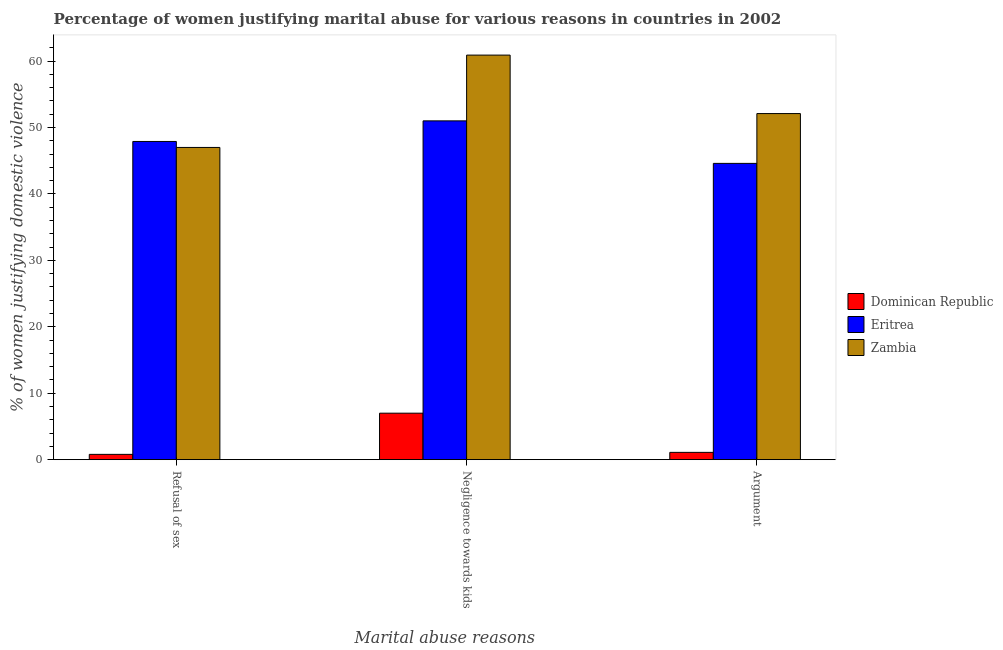How many groups of bars are there?
Keep it short and to the point. 3. Are the number of bars on each tick of the X-axis equal?
Give a very brief answer. Yes. What is the label of the 3rd group of bars from the left?
Your answer should be compact. Argument. What is the percentage of women justifying domestic violence due to arguments in Zambia?
Make the answer very short. 52.1. Across all countries, what is the maximum percentage of women justifying domestic violence due to refusal of sex?
Offer a very short reply. 47.9. Across all countries, what is the minimum percentage of women justifying domestic violence due to refusal of sex?
Provide a short and direct response. 0.8. In which country was the percentage of women justifying domestic violence due to arguments maximum?
Your answer should be very brief. Zambia. In which country was the percentage of women justifying domestic violence due to refusal of sex minimum?
Your response must be concise. Dominican Republic. What is the total percentage of women justifying domestic violence due to negligence towards kids in the graph?
Keep it short and to the point. 118.9. What is the difference between the percentage of women justifying domestic violence due to arguments in Dominican Republic and that in Eritrea?
Provide a short and direct response. -43.5. What is the difference between the percentage of women justifying domestic violence due to negligence towards kids in Dominican Republic and the percentage of women justifying domestic violence due to refusal of sex in Eritrea?
Offer a terse response. -40.9. What is the average percentage of women justifying domestic violence due to refusal of sex per country?
Provide a short and direct response. 31.9. What is the difference between the percentage of women justifying domestic violence due to negligence towards kids and percentage of women justifying domestic violence due to refusal of sex in Dominican Republic?
Offer a very short reply. 6.2. In how many countries, is the percentage of women justifying domestic violence due to arguments greater than 52 %?
Your answer should be compact. 1. What is the ratio of the percentage of women justifying domestic violence due to refusal of sex in Dominican Republic to that in Zambia?
Give a very brief answer. 0.02. Is the percentage of women justifying domestic violence due to negligence towards kids in Eritrea less than that in Dominican Republic?
Offer a terse response. No. What is the difference between the highest and the second highest percentage of women justifying domestic violence due to refusal of sex?
Provide a short and direct response. 0.9. What is the difference between the highest and the lowest percentage of women justifying domestic violence due to arguments?
Give a very brief answer. 51. In how many countries, is the percentage of women justifying domestic violence due to arguments greater than the average percentage of women justifying domestic violence due to arguments taken over all countries?
Offer a terse response. 2. Is the sum of the percentage of women justifying domestic violence due to arguments in Eritrea and Zambia greater than the maximum percentage of women justifying domestic violence due to refusal of sex across all countries?
Offer a very short reply. Yes. What does the 1st bar from the left in Refusal of sex represents?
Give a very brief answer. Dominican Republic. What does the 1st bar from the right in Refusal of sex represents?
Your response must be concise. Zambia. Are all the bars in the graph horizontal?
Ensure brevity in your answer.  No. Does the graph contain any zero values?
Make the answer very short. No. Does the graph contain grids?
Your answer should be very brief. No. What is the title of the graph?
Provide a succinct answer. Percentage of women justifying marital abuse for various reasons in countries in 2002. Does "Barbados" appear as one of the legend labels in the graph?
Offer a terse response. No. What is the label or title of the X-axis?
Provide a succinct answer. Marital abuse reasons. What is the label or title of the Y-axis?
Ensure brevity in your answer.  % of women justifying domestic violence. What is the % of women justifying domestic violence of Eritrea in Refusal of sex?
Provide a succinct answer. 47.9. What is the % of women justifying domestic violence of Zambia in Refusal of sex?
Provide a short and direct response. 47. What is the % of women justifying domestic violence in Zambia in Negligence towards kids?
Give a very brief answer. 60.9. What is the % of women justifying domestic violence of Eritrea in Argument?
Your answer should be very brief. 44.6. What is the % of women justifying domestic violence in Zambia in Argument?
Your response must be concise. 52.1. Across all Marital abuse reasons, what is the maximum % of women justifying domestic violence in Eritrea?
Provide a succinct answer. 51. Across all Marital abuse reasons, what is the maximum % of women justifying domestic violence in Zambia?
Make the answer very short. 60.9. Across all Marital abuse reasons, what is the minimum % of women justifying domestic violence of Dominican Republic?
Offer a very short reply. 0.8. Across all Marital abuse reasons, what is the minimum % of women justifying domestic violence of Eritrea?
Your answer should be very brief. 44.6. Across all Marital abuse reasons, what is the minimum % of women justifying domestic violence in Zambia?
Make the answer very short. 47. What is the total % of women justifying domestic violence of Eritrea in the graph?
Provide a succinct answer. 143.5. What is the total % of women justifying domestic violence in Zambia in the graph?
Provide a short and direct response. 160. What is the difference between the % of women justifying domestic violence in Dominican Republic in Refusal of sex and that in Negligence towards kids?
Your response must be concise. -6.2. What is the difference between the % of women justifying domestic violence in Eritrea in Refusal of sex and that in Negligence towards kids?
Make the answer very short. -3.1. What is the difference between the % of women justifying domestic violence in Zambia in Refusal of sex and that in Negligence towards kids?
Offer a terse response. -13.9. What is the difference between the % of women justifying domestic violence in Eritrea in Refusal of sex and that in Argument?
Keep it short and to the point. 3.3. What is the difference between the % of women justifying domestic violence in Zambia in Refusal of sex and that in Argument?
Your response must be concise. -5.1. What is the difference between the % of women justifying domestic violence of Dominican Republic in Negligence towards kids and that in Argument?
Ensure brevity in your answer.  5.9. What is the difference between the % of women justifying domestic violence of Dominican Republic in Refusal of sex and the % of women justifying domestic violence of Eritrea in Negligence towards kids?
Offer a terse response. -50.2. What is the difference between the % of women justifying domestic violence of Dominican Republic in Refusal of sex and the % of women justifying domestic violence of Zambia in Negligence towards kids?
Keep it short and to the point. -60.1. What is the difference between the % of women justifying domestic violence in Eritrea in Refusal of sex and the % of women justifying domestic violence in Zambia in Negligence towards kids?
Your answer should be very brief. -13. What is the difference between the % of women justifying domestic violence in Dominican Republic in Refusal of sex and the % of women justifying domestic violence in Eritrea in Argument?
Keep it short and to the point. -43.8. What is the difference between the % of women justifying domestic violence of Dominican Republic in Refusal of sex and the % of women justifying domestic violence of Zambia in Argument?
Ensure brevity in your answer.  -51.3. What is the difference between the % of women justifying domestic violence in Eritrea in Refusal of sex and the % of women justifying domestic violence in Zambia in Argument?
Provide a short and direct response. -4.2. What is the difference between the % of women justifying domestic violence in Dominican Republic in Negligence towards kids and the % of women justifying domestic violence in Eritrea in Argument?
Your response must be concise. -37.6. What is the difference between the % of women justifying domestic violence in Dominican Republic in Negligence towards kids and the % of women justifying domestic violence in Zambia in Argument?
Your response must be concise. -45.1. What is the average % of women justifying domestic violence in Dominican Republic per Marital abuse reasons?
Give a very brief answer. 2.97. What is the average % of women justifying domestic violence in Eritrea per Marital abuse reasons?
Give a very brief answer. 47.83. What is the average % of women justifying domestic violence of Zambia per Marital abuse reasons?
Make the answer very short. 53.33. What is the difference between the % of women justifying domestic violence in Dominican Republic and % of women justifying domestic violence in Eritrea in Refusal of sex?
Give a very brief answer. -47.1. What is the difference between the % of women justifying domestic violence in Dominican Republic and % of women justifying domestic violence in Zambia in Refusal of sex?
Ensure brevity in your answer.  -46.2. What is the difference between the % of women justifying domestic violence of Eritrea and % of women justifying domestic violence of Zambia in Refusal of sex?
Ensure brevity in your answer.  0.9. What is the difference between the % of women justifying domestic violence of Dominican Republic and % of women justifying domestic violence of Eritrea in Negligence towards kids?
Offer a very short reply. -44. What is the difference between the % of women justifying domestic violence of Dominican Republic and % of women justifying domestic violence of Zambia in Negligence towards kids?
Make the answer very short. -53.9. What is the difference between the % of women justifying domestic violence in Eritrea and % of women justifying domestic violence in Zambia in Negligence towards kids?
Make the answer very short. -9.9. What is the difference between the % of women justifying domestic violence in Dominican Republic and % of women justifying domestic violence in Eritrea in Argument?
Your answer should be compact. -43.5. What is the difference between the % of women justifying domestic violence in Dominican Republic and % of women justifying domestic violence in Zambia in Argument?
Give a very brief answer. -51. What is the difference between the % of women justifying domestic violence of Eritrea and % of women justifying domestic violence of Zambia in Argument?
Ensure brevity in your answer.  -7.5. What is the ratio of the % of women justifying domestic violence of Dominican Republic in Refusal of sex to that in Negligence towards kids?
Offer a terse response. 0.11. What is the ratio of the % of women justifying domestic violence of Eritrea in Refusal of sex to that in Negligence towards kids?
Give a very brief answer. 0.94. What is the ratio of the % of women justifying domestic violence in Zambia in Refusal of sex to that in Negligence towards kids?
Your response must be concise. 0.77. What is the ratio of the % of women justifying domestic violence of Dominican Republic in Refusal of sex to that in Argument?
Your response must be concise. 0.73. What is the ratio of the % of women justifying domestic violence of Eritrea in Refusal of sex to that in Argument?
Keep it short and to the point. 1.07. What is the ratio of the % of women justifying domestic violence in Zambia in Refusal of sex to that in Argument?
Your answer should be very brief. 0.9. What is the ratio of the % of women justifying domestic violence of Dominican Republic in Negligence towards kids to that in Argument?
Offer a terse response. 6.36. What is the ratio of the % of women justifying domestic violence of Eritrea in Negligence towards kids to that in Argument?
Offer a very short reply. 1.14. What is the ratio of the % of women justifying domestic violence in Zambia in Negligence towards kids to that in Argument?
Provide a succinct answer. 1.17. What is the difference between the highest and the second highest % of women justifying domestic violence in Dominican Republic?
Provide a short and direct response. 5.9. What is the difference between the highest and the second highest % of women justifying domestic violence of Zambia?
Make the answer very short. 8.8. 